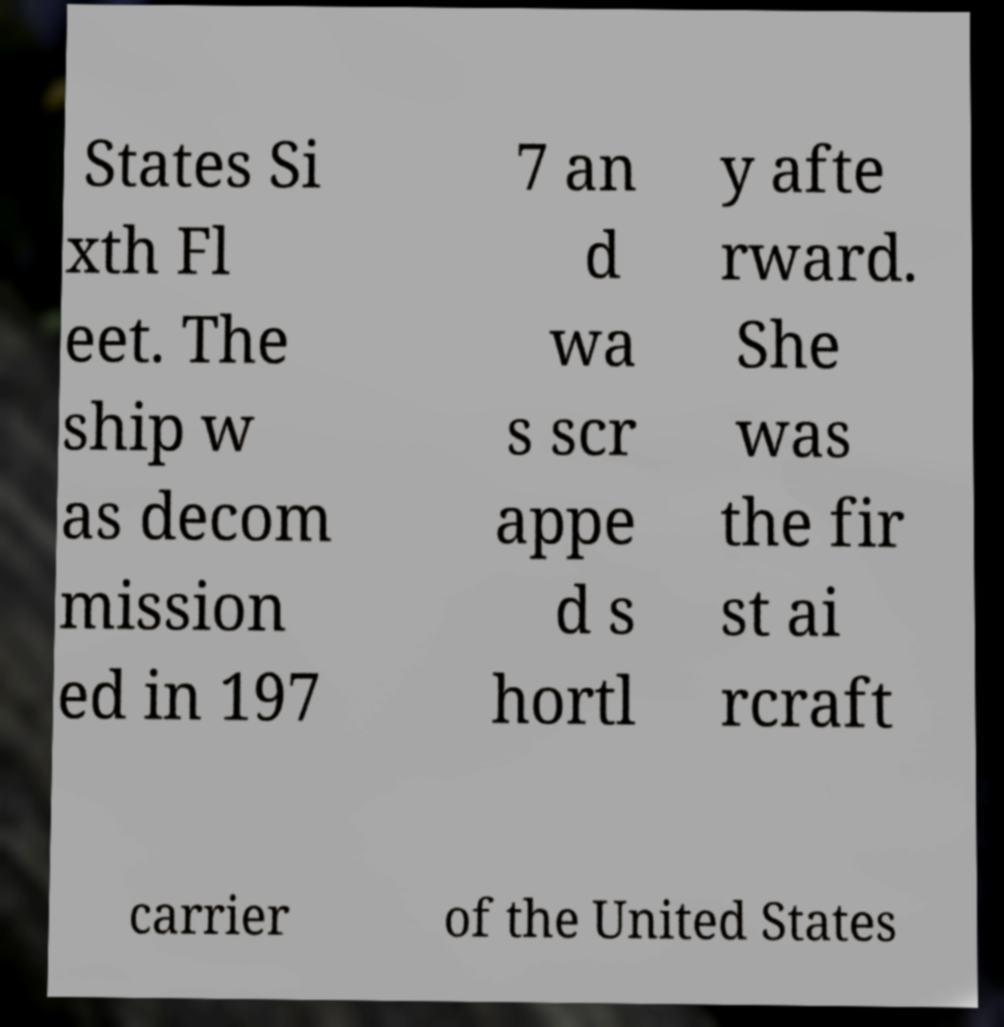I need the written content from this picture converted into text. Can you do that? States Si xth Fl eet. The ship w as decom mission ed in 197 7 an d wa s scr appe d s hortl y afte rward. She was the fir st ai rcraft carrier of the United States 